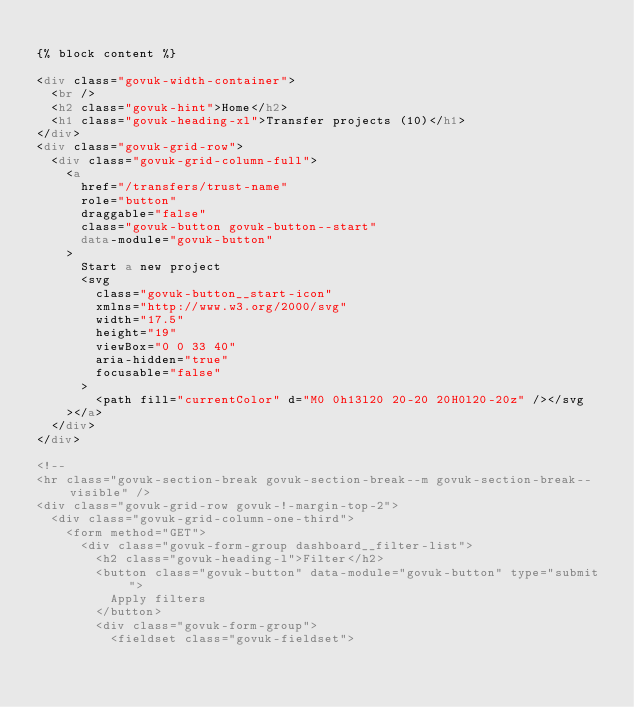Convert code to text. <code><loc_0><loc_0><loc_500><loc_500><_HTML_>
{% block content %}

<div class="govuk-width-container">
  <br />
  <h2 class="govuk-hint">Home</h2>
  <h1 class="govuk-heading-xl">Transfer projects (10)</h1>
</div>
<div class="govuk-grid-row">
  <div class="govuk-grid-column-full">
    <a
      href="/transfers/trust-name"
      role="button"
      draggable="false"
      class="govuk-button govuk-button--start"
      data-module="govuk-button"
    >
      Start a new project
      <svg
        class="govuk-button__start-icon"
        xmlns="http://www.w3.org/2000/svg"
        width="17.5"
        height="19"
        viewBox="0 0 33 40"
        aria-hidden="true"
        focusable="false"
      >
        <path fill="currentColor" d="M0 0h13l20 20-20 20H0l20-20z" /></svg
    ></a>
  </div>
</div>

<!--
<hr class="govuk-section-break govuk-section-break--m govuk-section-break--visible" />
<div class="govuk-grid-row govuk-!-margin-top-2">
  <div class="govuk-grid-column-one-third">
    <form method="GET">
      <div class="govuk-form-group dashboard__filter-list">
        <h2 class="govuk-heading-l">Filter</h2>
        <button class="govuk-button" data-module="govuk-button" type="submit">
          Apply filters
        </button>
        <div class="govuk-form-group">
          <fieldset class="govuk-fieldset"></code> 